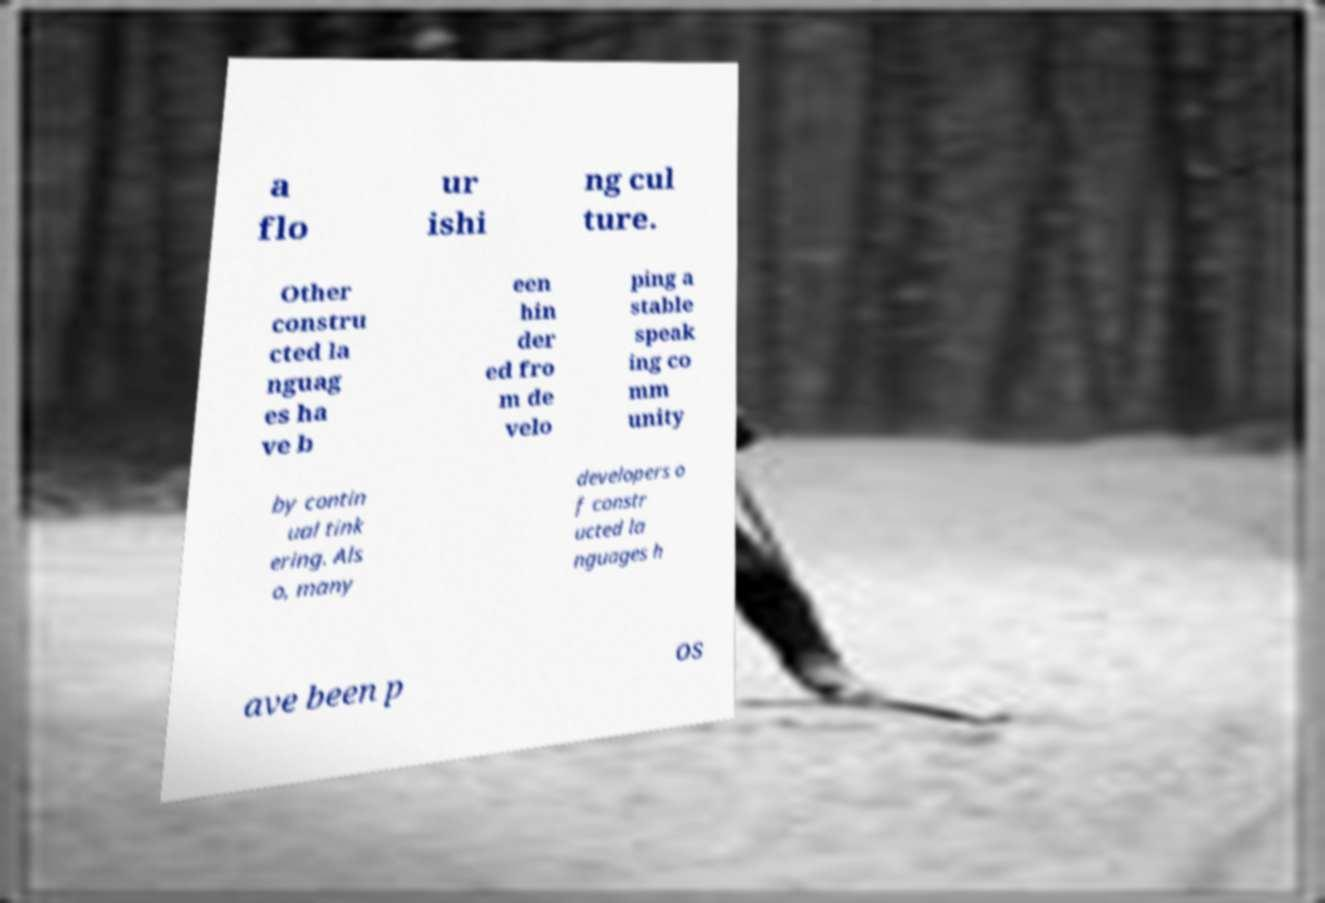Could you extract and type out the text from this image? a flo ur ishi ng cul ture. Other constru cted la nguag es ha ve b een hin der ed fro m de velo ping a stable speak ing co mm unity by contin ual tink ering. Als o, many developers o f constr ucted la nguages h ave been p os 